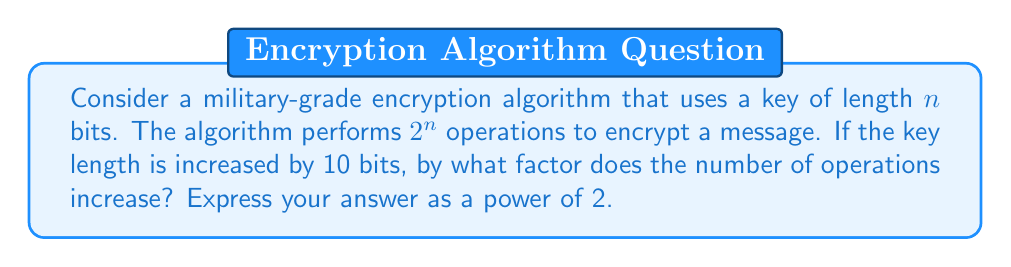Can you answer this question? Let's approach this step-by-step:

1) With a key length of $n$ bits, the number of operations is $2^n$.

2) When the key length is increased by 10 bits, the new key length is $n + 10$ bits.

3) With this new key length, the number of operations becomes $2^{n+10}$.

4) To find the factor of increase, we need to divide the new number of operations by the original number of operations:

   $$\frac{2^{n+10}}{2^n}$$

5) Using the laws of exponents, this simplifies to:

   $$2^{n+10-n} = 2^{10}$$

6) Therefore, the number of operations increases by a factor of $2^{10}$.

This result is significant in the context of military communications. It demonstrates that even a relatively small increase in key length (10 bits) can lead to a substantial increase in computational complexity (1024 times more operations). This exponential growth in complexity is a key feature of many encryption algorithms, making them resistant to brute-force attacks even as computing power increases over time.
Answer: $2^{10}$ 